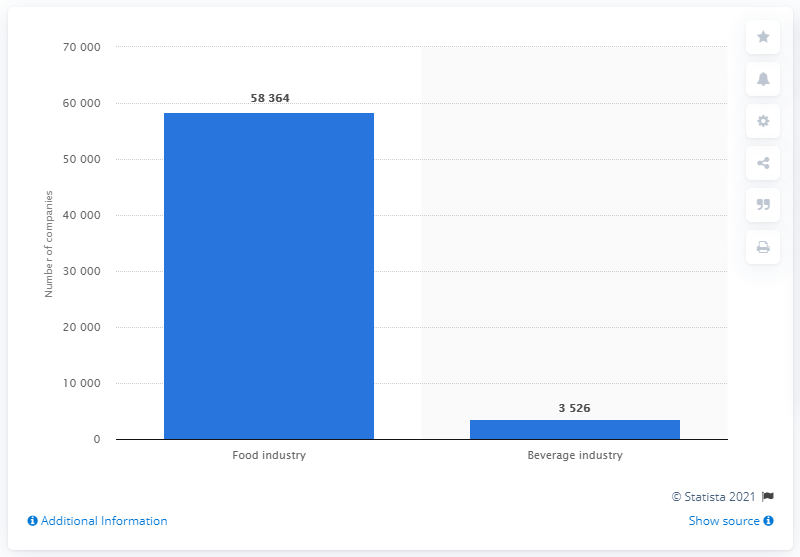What does this graph tell us about the beverage industry in Italy during the same period? The graph shows that there were 3,526 companies in the beverage industry in Italy during the second quarter of 2017, illustrating a smaller but vital segment of Italy's economy, focused on the production and distribution of beverages. 